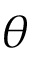<formula> <loc_0><loc_0><loc_500><loc_500>\theta</formula> 